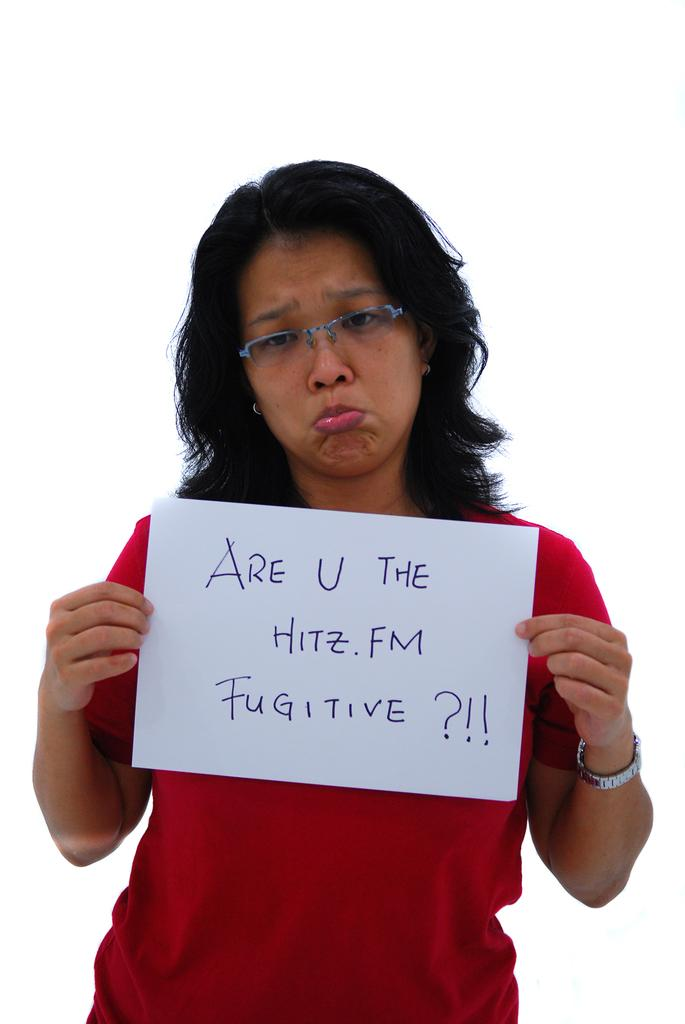<image>
Give a short and clear explanation of the subsequent image. A woman is pouting and holding a sign that says, 'Are u the hitz.fm fugitive?!!'. 